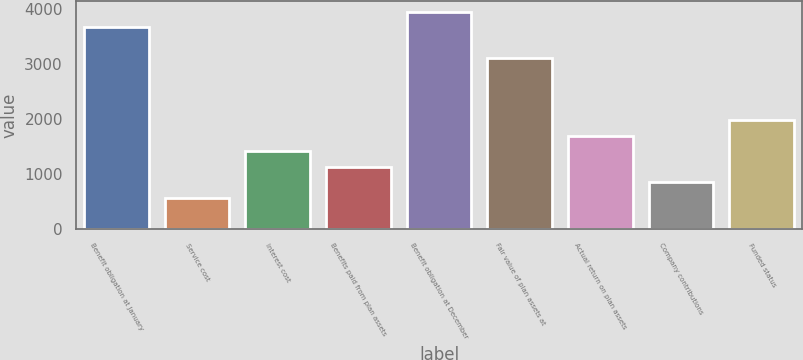<chart> <loc_0><loc_0><loc_500><loc_500><bar_chart><fcel>Benefit obligation at January<fcel>Service cost<fcel>Interest cost<fcel>Benefits paid from plan assets<fcel>Benefit obligation at December<fcel>Fair value of plan assets at<fcel>Actual return on plan assets<fcel>Company contributions<fcel>Funded status<nl><fcel>3666.7<fcel>565.8<fcel>1411.5<fcel>1129.6<fcel>3948.6<fcel>3102.9<fcel>1693.4<fcel>847.7<fcel>1975.3<nl></chart> 